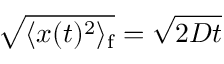<formula> <loc_0><loc_0><loc_500><loc_500>\sqrt { \langle x ( t ) ^ { 2 } \rangle _ { f } } = \sqrt { 2 D t }</formula> 